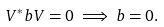<formula> <loc_0><loc_0><loc_500><loc_500>V ^ { * } b V = 0 \implies b = 0 .</formula> 